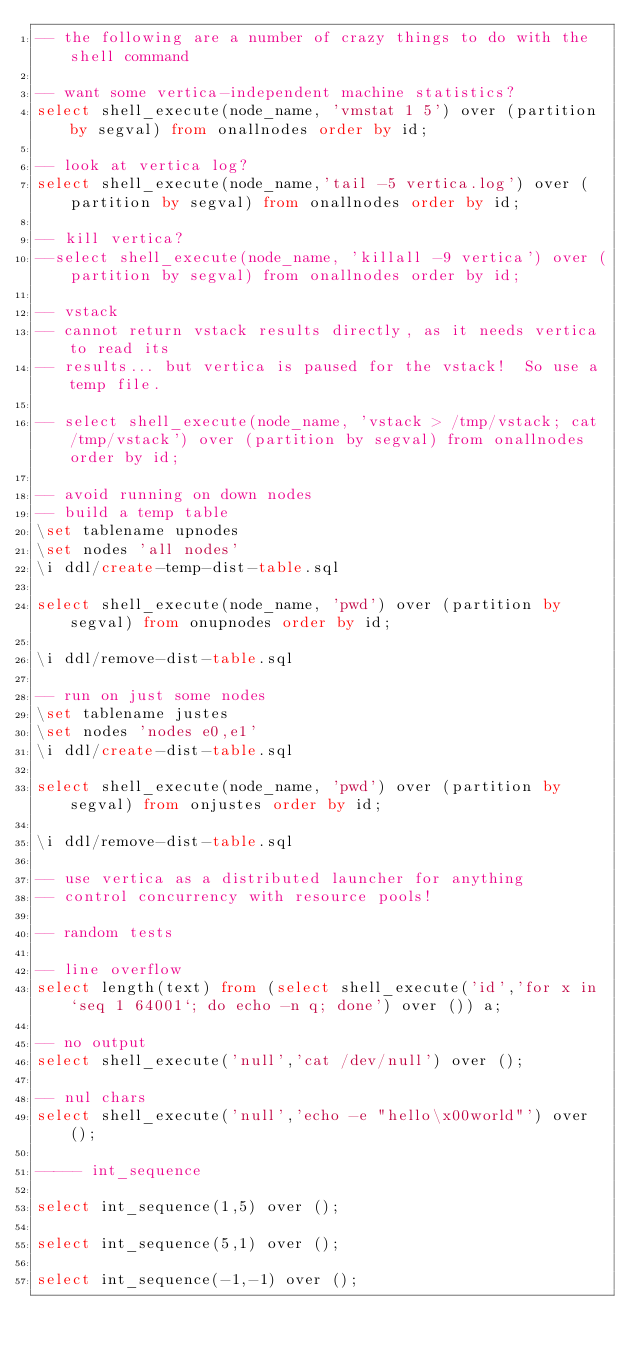Convert code to text. <code><loc_0><loc_0><loc_500><loc_500><_SQL_>-- the following are a number of crazy things to do with the shell command

-- want some vertica-independent machine statistics?
select shell_execute(node_name, 'vmstat 1 5') over (partition by segval) from onallnodes order by id;

-- look at vertica log?
select shell_execute(node_name,'tail -5 vertica.log') over (partition by segval) from onallnodes order by id;

-- kill vertica?
--select shell_execute(node_name, 'killall -9 vertica') over (partition by segval) from onallnodes order by id;

-- vstack
-- cannot return vstack results directly, as it needs vertica to read its
-- results... but vertica is paused for the vstack!  So use a temp file.

-- select shell_execute(node_name, 'vstack > /tmp/vstack; cat /tmp/vstack') over (partition by segval) from onallnodes order by id;

-- avoid running on down nodes
-- build a temp table
\set tablename upnodes
\set nodes 'all nodes'
\i ddl/create-temp-dist-table.sql

select shell_execute(node_name, 'pwd') over (partition by segval) from onupnodes order by id;

\i ddl/remove-dist-table.sql

-- run on just some nodes
\set tablename justes
\set nodes 'nodes e0,e1'
\i ddl/create-dist-table.sql

select shell_execute(node_name, 'pwd') over (partition by segval) from onjustes order by id;

\i ddl/remove-dist-table.sql

-- use vertica as a distributed launcher for anything
-- control concurrency with resource pools!

-- random tests

-- line overflow
select length(text) from (select shell_execute('id','for x in `seq 1 64001`; do echo -n q; done') over ()) a;

-- no output
select shell_execute('null','cat /dev/null') over ();

-- nul chars
select shell_execute('null','echo -e "hello\x00world"') over ();

----- int_sequence

select int_sequence(1,5) over ();

select int_sequence(5,1) over ();

select int_sequence(-1,-1) over ();

</code> 